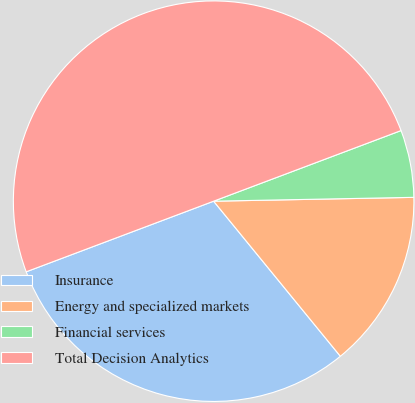Convert chart to OTSL. <chart><loc_0><loc_0><loc_500><loc_500><pie_chart><fcel>Insurance<fcel>Energy and specialized markets<fcel>Financial services<fcel>Total Decision Analytics<nl><fcel>30.17%<fcel>14.4%<fcel>5.43%<fcel>50.0%<nl></chart> 